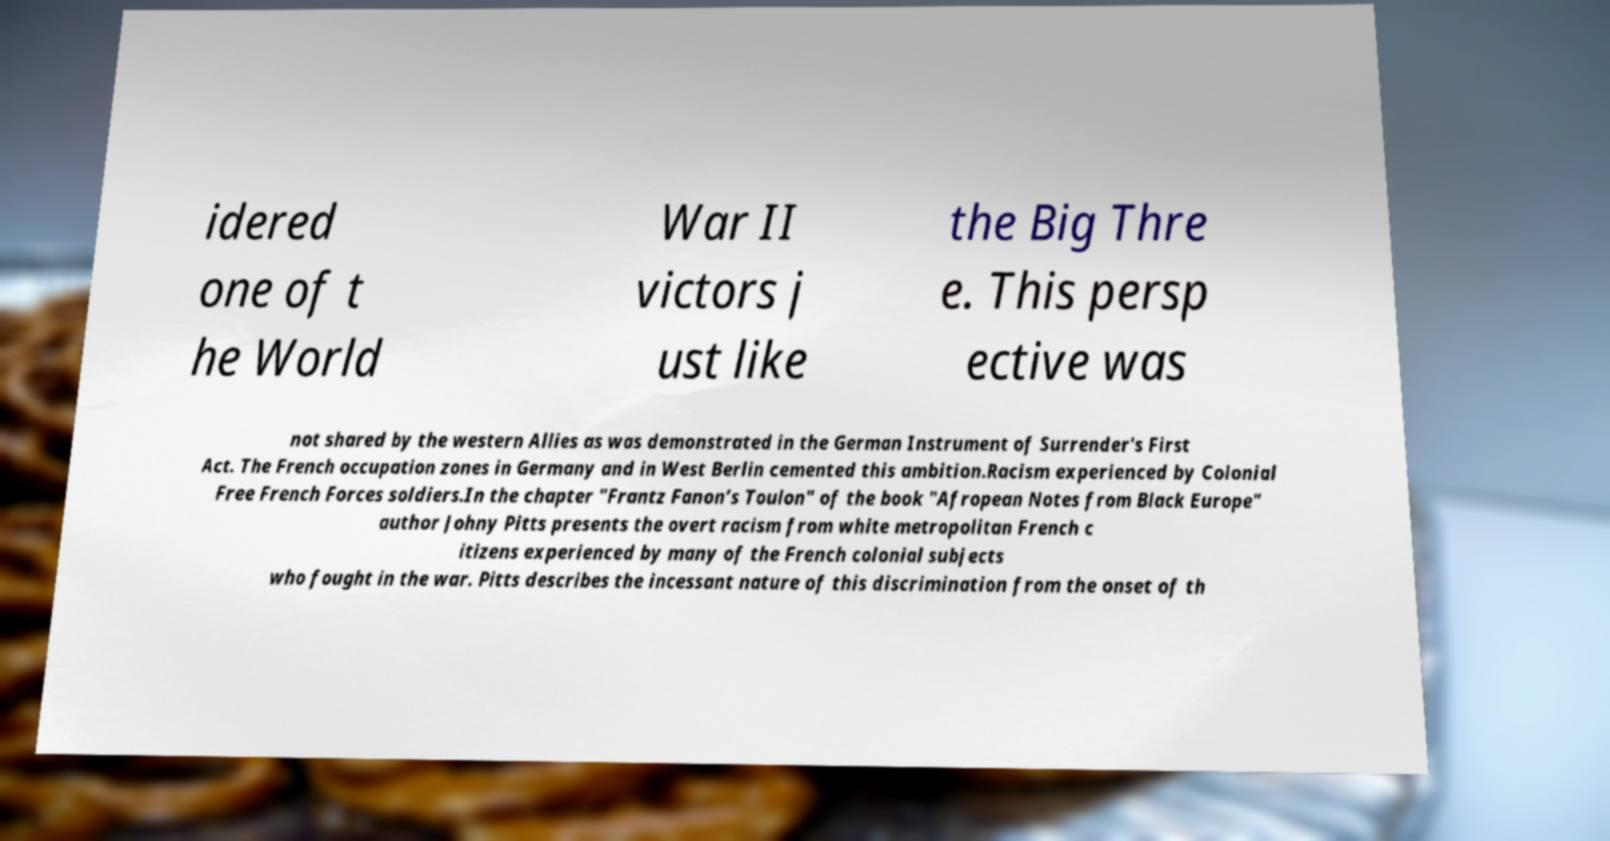Could you assist in decoding the text presented in this image and type it out clearly? idered one of t he World War II victors j ust like the Big Thre e. This persp ective was not shared by the western Allies as was demonstrated in the German Instrument of Surrender's First Act. The French occupation zones in Germany and in West Berlin cemented this ambition.Racism experienced by Colonial Free French Forces soldiers.In the chapter "Frantz Fanon’s Toulon" of the book "Afropean Notes from Black Europe" author Johny Pitts presents the overt racism from white metropolitan French c itizens experienced by many of the French colonial subjects who fought in the war. Pitts describes the incessant nature of this discrimination from the onset of th 